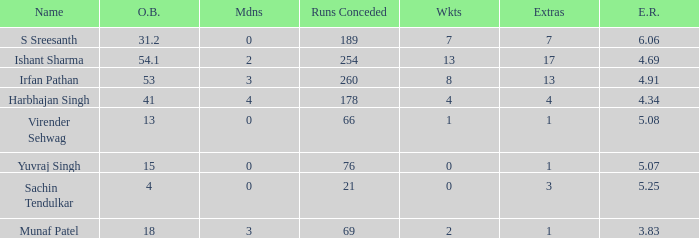What is the term for when 3 S Sreesanth. 